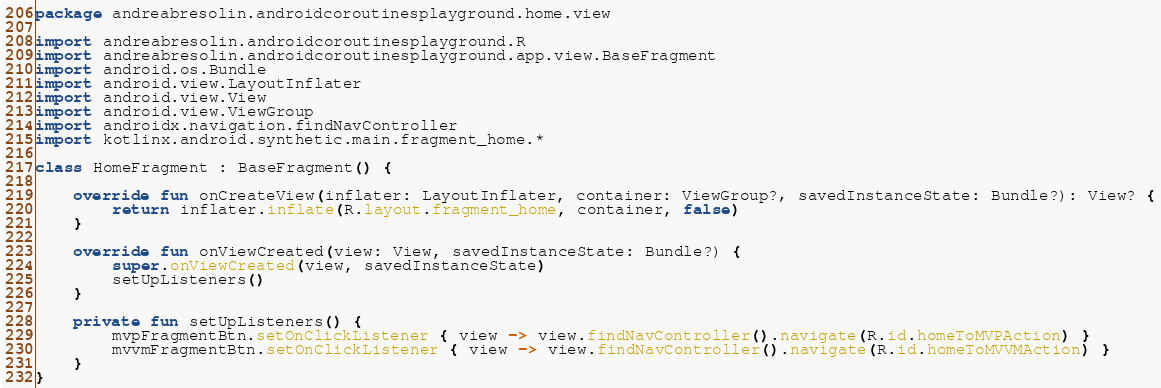Convert code to text. <code><loc_0><loc_0><loc_500><loc_500><_Kotlin_>package andreabresolin.androidcoroutinesplayground.home.view

import andreabresolin.androidcoroutinesplayground.R
import andreabresolin.androidcoroutinesplayground.app.view.BaseFragment
import android.os.Bundle
import android.view.LayoutInflater
import android.view.View
import android.view.ViewGroup
import androidx.navigation.findNavController
import kotlinx.android.synthetic.main.fragment_home.*

class HomeFragment : BaseFragment() {

    override fun onCreateView(inflater: LayoutInflater, container: ViewGroup?, savedInstanceState: Bundle?): View? {
        return inflater.inflate(R.layout.fragment_home, container, false)
    }

    override fun onViewCreated(view: View, savedInstanceState: Bundle?) {
        super.onViewCreated(view, savedInstanceState)
        setUpListeners()
    }

    private fun setUpListeners() {
        mvpFragmentBtn.setOnClickListener { view -> view.findNavController().navigate(R.id.homeToMVPAction) }
        mvvmFragmentBtn.setOnClickListener { view -> view.findNavController().navigate(R.id.homeToMVVMAction) }
    }
}
</code> 